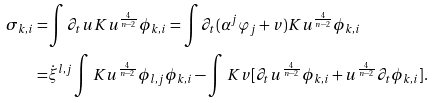Convert formula to latex. <formula><loc_0><loc_0><loc_500><loc_500>\sigma _ { k , i } = & \int \partial _ { t } u K u ^ { \frac { 4 } { n - 2 } } \phi _ { k , i } = \int \partial _ { t } ( \alpha ^ { j } \varphi _ { j } + v ) K u ^ { \frac { 4 } { n - 2 } } \phi _ { k , i } \\ = & \dot { \xi } ^ { l , j } \int K u ^ { \frac { 4 } { n - 2 } } \phi _ { l , j } \phi _ { k , i } - \int K v [ \partial _ { t } u ^ { \frac { 4 } { n - 2 } } \phi _ { k , i } + u ^ { \frac { 4 } { n - 2 } } \partial _ { t } \phi _ { k , i } ] .</formula> 